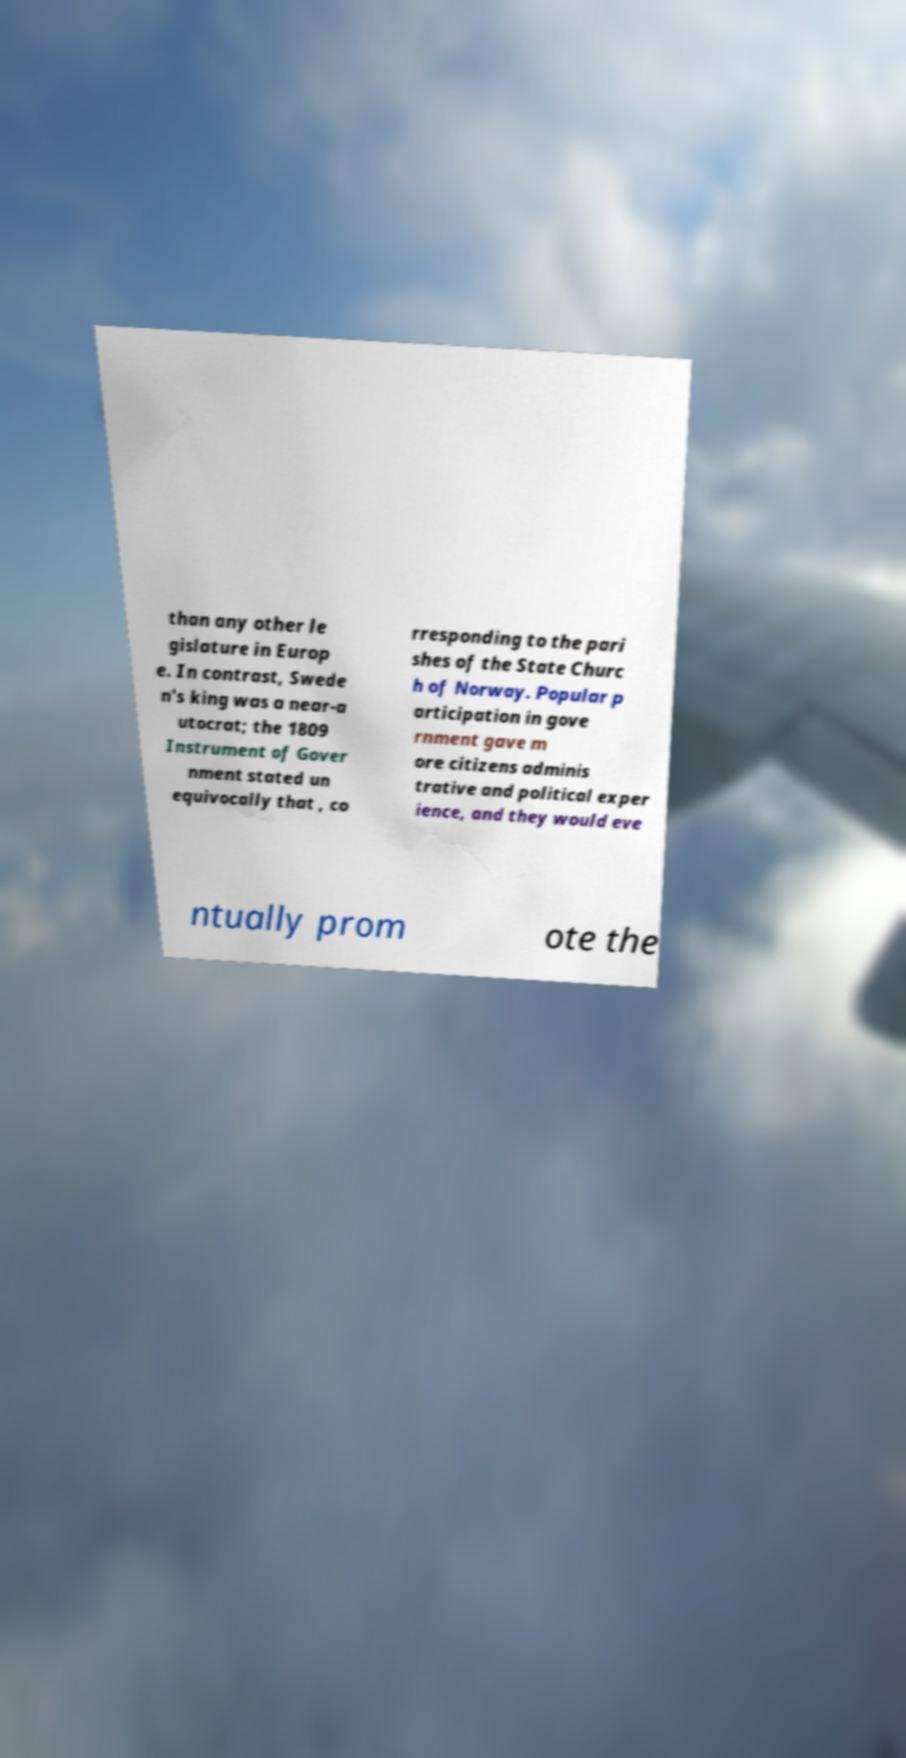What messages or text are displayed in this image? I need them in a readable, typed format. than any other le gislature in Europ e. In contrast, Swede n's king was a near-a utocrat; the 1809 Instrument of Gover nment stated un equivocally that , co rresponding to the pari shes of the State Churc h of Norway. Popular p articipation in gove rnment gave m ore citizens adminis trative and political exper ience, and they would eve ntually prom ote the 